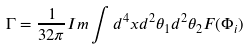<formula> <loc_0><loc_0><loc_500><loc_500>\Gamma = \frac { 1 } { 3 2 \pi } I m \int d ^ { 4 } x d ^ { 2 } \theta _ { 1 } d ^ { 2 } \theta _ { 2 } F ( \Phi _ { i } )</formula> 